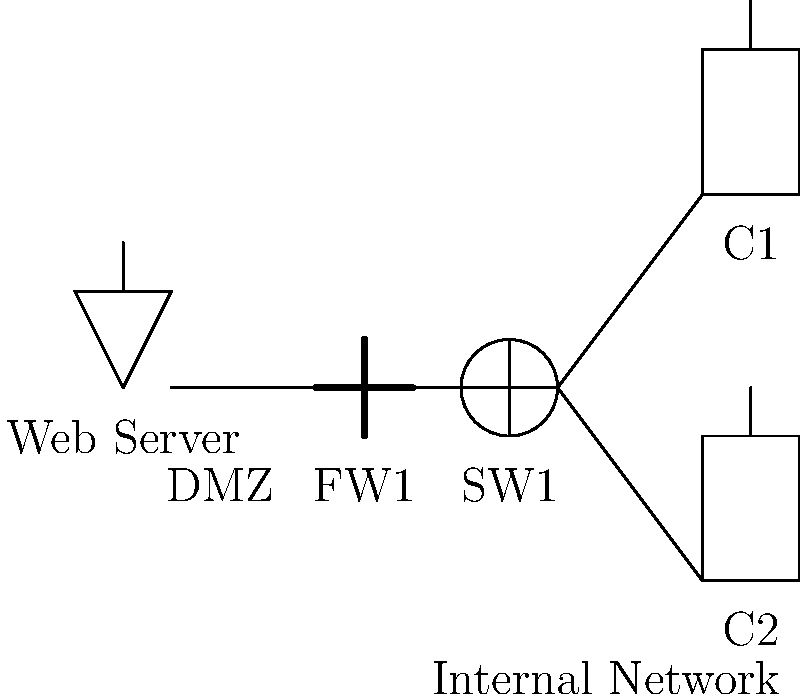Identify the potential security vulnerability in the given network topology diagram: To identify the security vulnerability in this network topology, let's analyze the components and their connections:

1. We have a Web Server in what appears to be a DMZ (Demilitarized Zone).
2. There's a firewall (FW1) separating the DMZ from the internal network.
3. A switch (SW1) is present in the internal network.
4. Two clients (C1 and C2) are connected to the switch in the internal network.

The main security vulnerability in this topology is:

The lack of segmentation between the DMZ and the internal network. There's only one firewall (FW1) separating these two zones. This configuration doesn't provide adequate protection for the internal network if the DMZ is compromised.

Best practices for network security recommend:

1. Implementing a multi-tiered firewall architecture.
2. Having at least two firewalls: one between the DMZ and the external network, and another between the DMZ and the internal network.
3. This creates three distinct security zones: external, DMZ, and internal.

The current setup allows direct communication between the DMZ and the internal network through a single firewall, which increases the risk if the DMZ is compromised. An attacker who gains access to the Web Server could potentially exploit this single point of defense to access the internal network.
Answer: Insufficient network segmentation between DMZ and internal network 